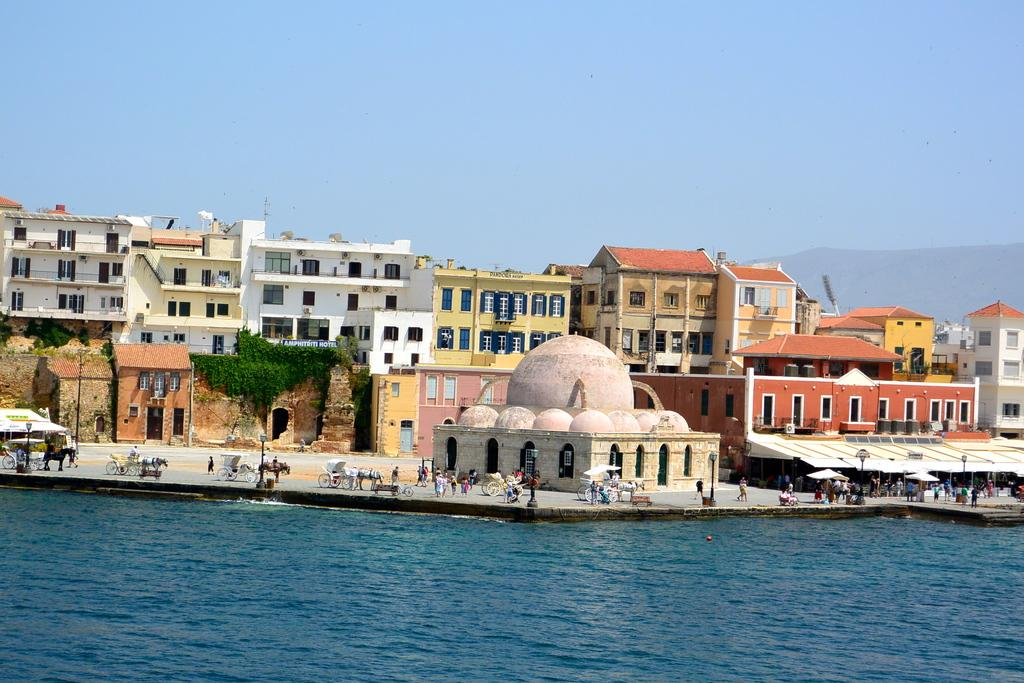What type of structures can be seen in the image? There are many buildings in the image. Who or what else can be seen in the image? There are many people and horse carts visible in the image. What is at the bottom of the image? There is water at the bottom of the image. What is visible at the top of the image? The sky is visible at the top of the image. What kind of operation is being performed on the son in the image? There is no son or operation present in the image. What does the image offer to the viewer? The image does not offer anything to the viewer; it is a static representation of the scene. 